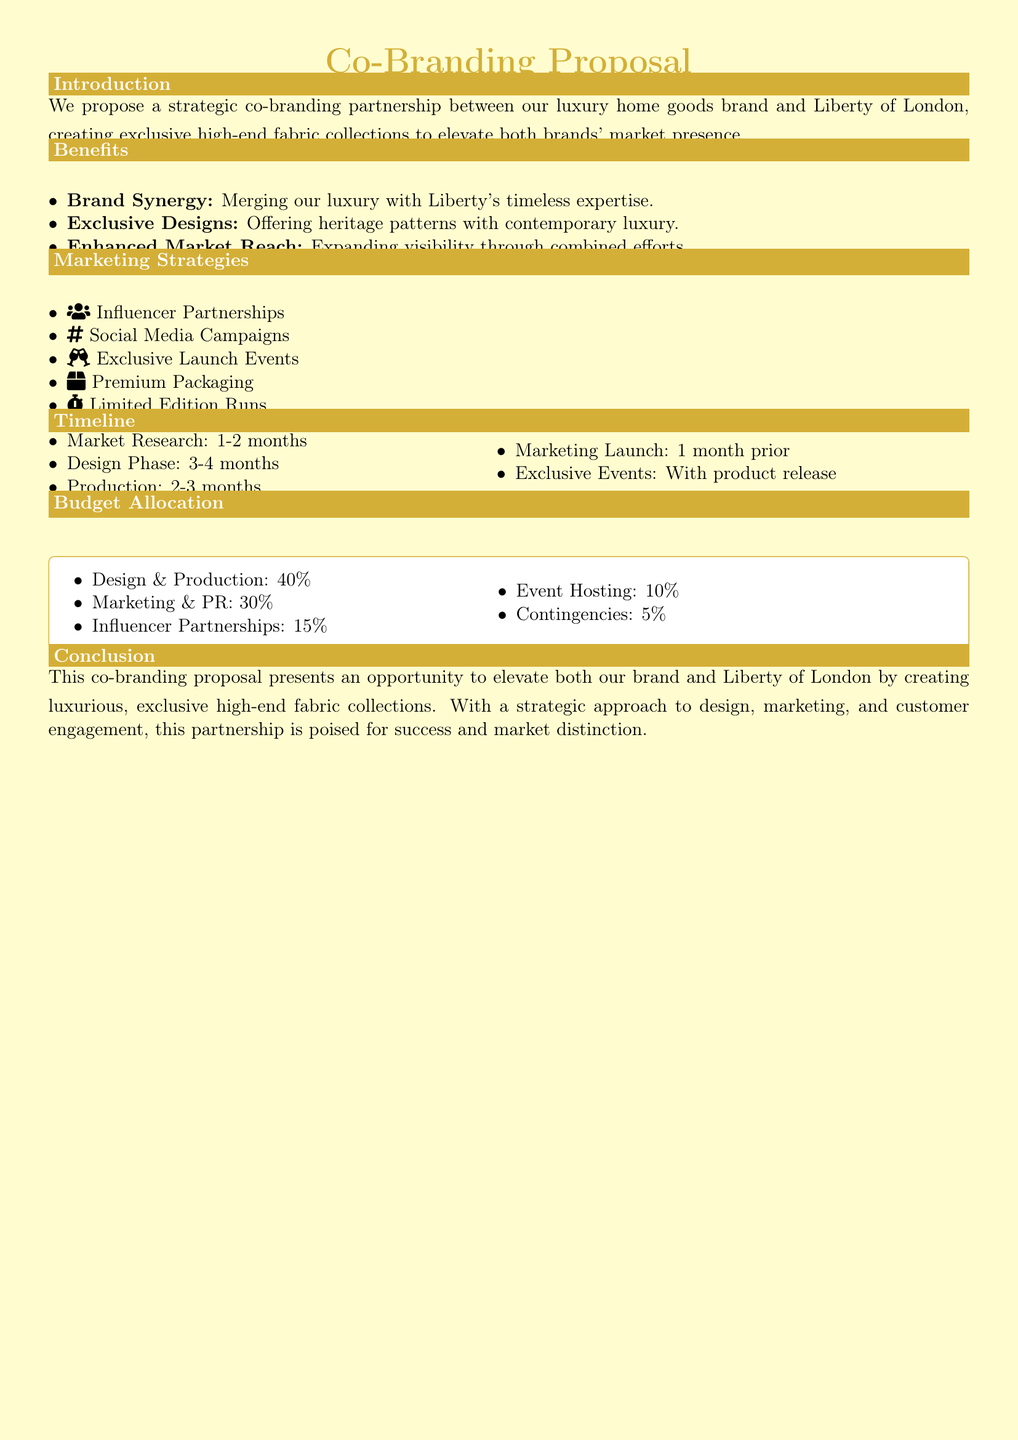What is the title of the proposal? The title of the proposal is stated at the beginning and is "Co-Branding Proposal."
Answer: Co-Branding Proposal What percentage of the budget is allocated to Design & Production? This information is found in the Budget Allocation section, which states that 40% is allocated to Design & Production.
Answer: 40% How long is the Design Phase scheduled to last? The duration of the Design Phase is included in the Timeline section, which indicates it lasts 3-4 months.
Answer: 3-4 months What marketing strategy involves social media? The document mentions "Social Media Campaigns" as one of the marketing strategies.
Answer: Social Media Campaigns What benefit relates to the combination of two brands? The first benefit discusses merging brands and is described as "Brand Synergy."
Answer: Brand Synergy Which exclusive event is mentioned in the marketing strategies? "Exclusive Launch Events" is listed among the marketing strategies as an exclusive event.
Answer: Exclusive Launch Events How much of the budget is designated for Influencer Partnerships? The Budget Allocation section specifies that 15% of the budget is set aside for Influencer Partnerships.
Answer: 15% What is the total timeline for Market Research and Design Phase combined? The total timeline for both phases is calculated as 1-2 months for Market Research plus 3-4 months for Design Phase, giving a collective duration of 4-6 months.
Answer: 4-6 months What is the primary objective of the proposal? The Conclusion states that the main objective is to elevate both brands by creating luxurious, exclusive high-end fabric collections.
Answer: Elevate both brands 